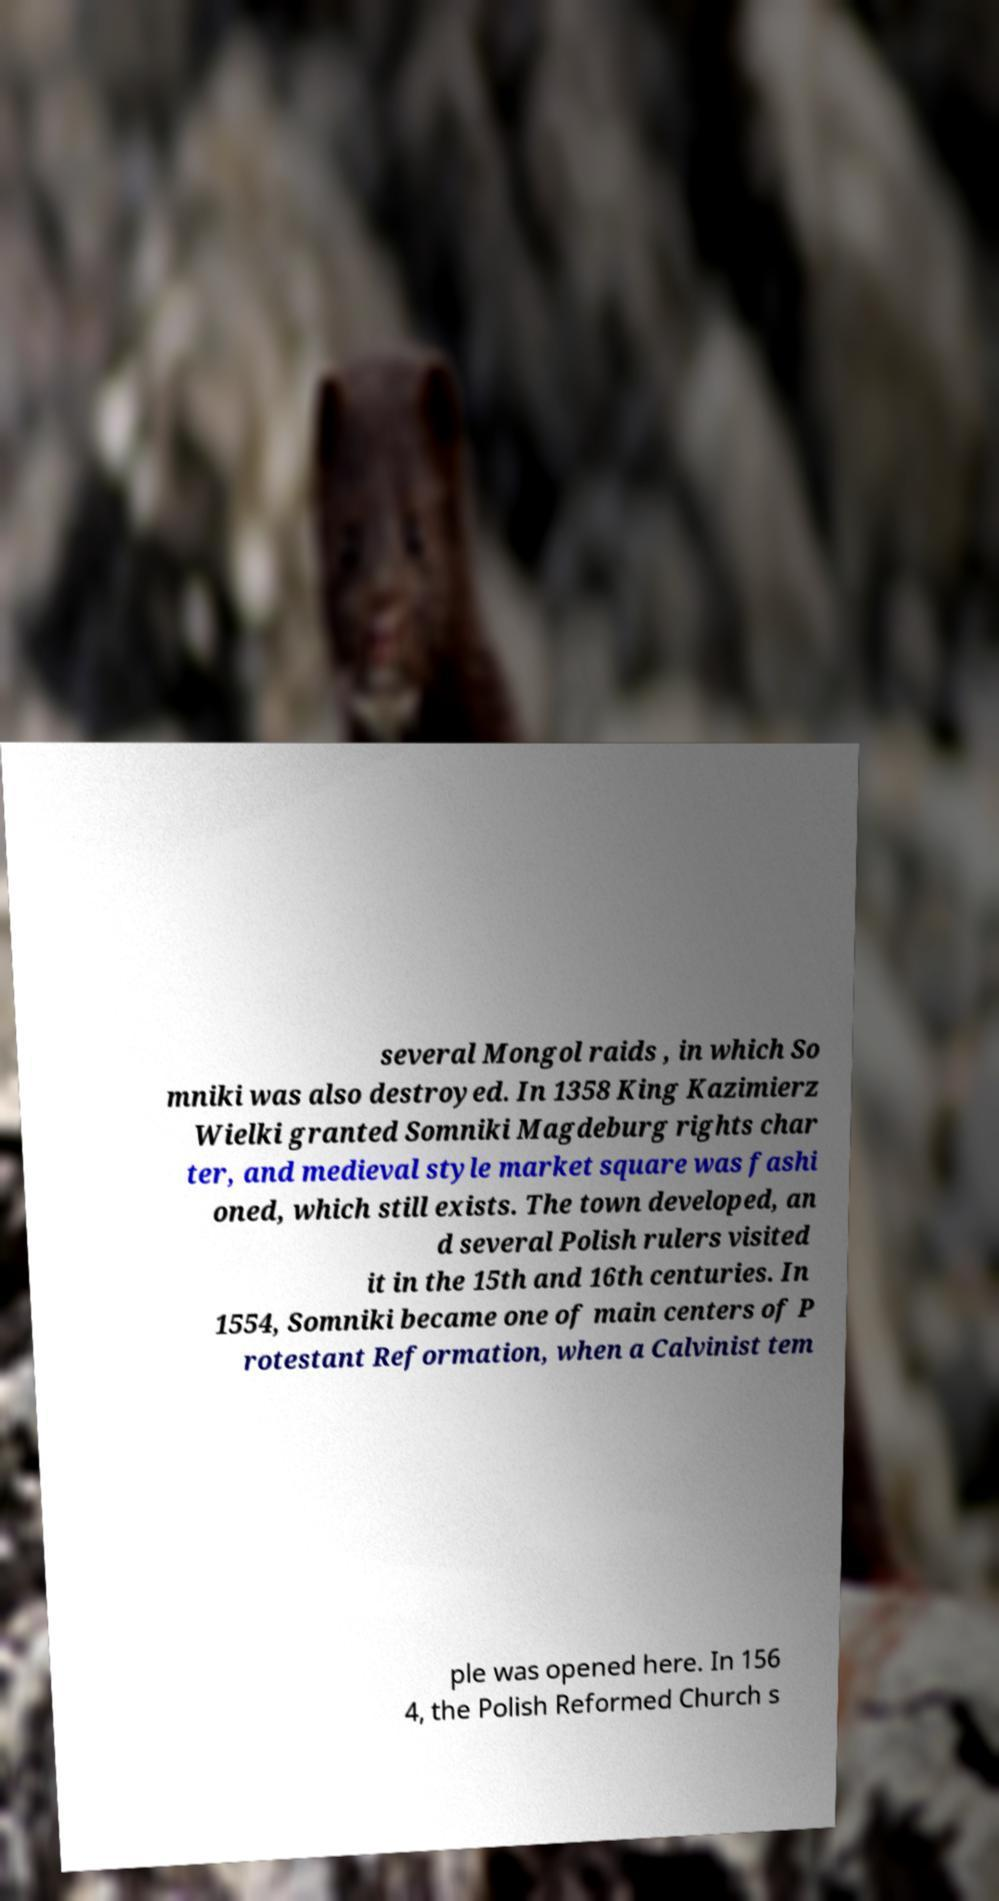For documentation purposes, I need the text within this image transcribed. Could you provide that? several Mongol raids , in which So mniki was also destroyed. In 1358 King Kazimierz Wielki granted Somniki Magdeburg rights char ter, and medieval style market square was fashi oned, which still exists. The town developed, an d several Polish rulers visited it in the 15th and 16th centuries. In 1554, Somniki became one of main centers of P rotestant Reformation, when a Calvinist tem ple was opened here. In 156 4, the Polish Reformed Church s 